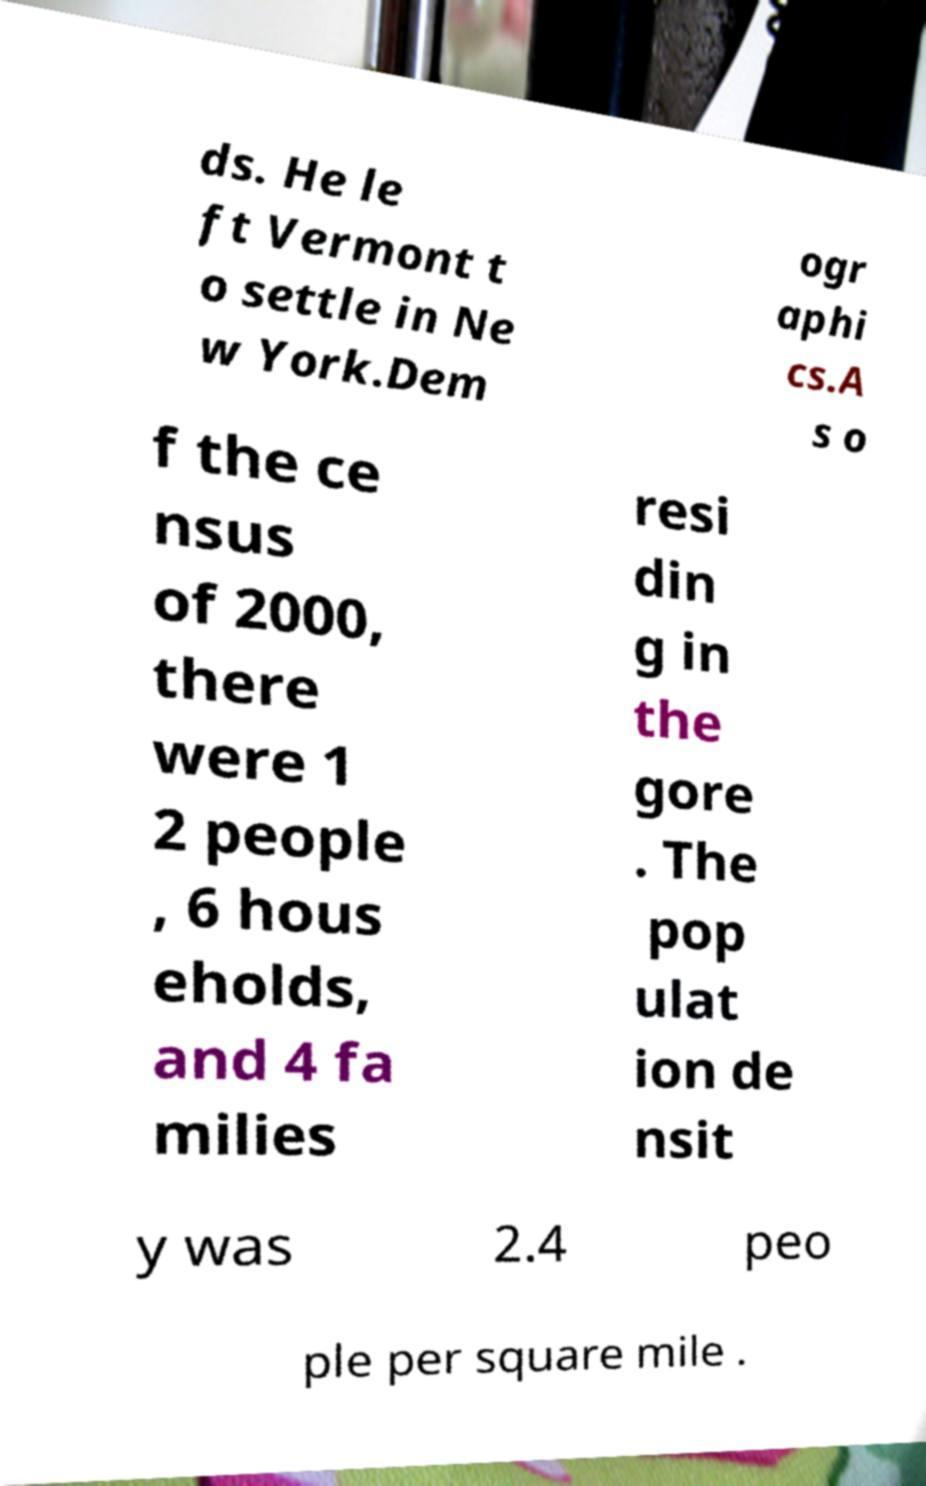Can you read and provide the text displayed in the image?This photo seems to have some interesting text. Can you extract and type it out for me? ds. He le ft Vermont t o settle in Ne w York.Dem ogr aphi cs.A s o f the ce nsus of 2000, there were 1 2 people , 6 hous eholds, and 4 fa milies resi din g in the gore . The pop ulat ion de nsit y was 2.4 peo ple per square mile . 